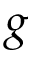Convert formula to latex. <formula><loc_0><loc_0><loc_500><loc_500>g</formula> 